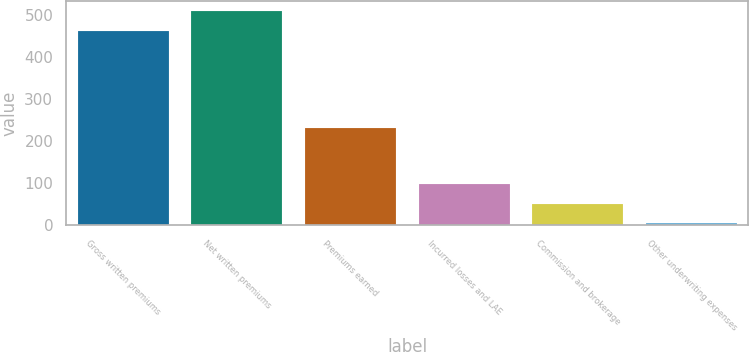Convert chart to OTSL. <chart><loc_0><loc_0><loc_500><loc_500><bar_chart><fcel>Gross written premiums<fcel>Net written premiums<fcel>Premiums earned<fcel>Incurred losses and LAE<fcel>Commission and brokerage<fcel>Other underwriting expenses<nl><fcel>461.3<fcel>507.38<fcel>230.9<fcel>97.76<fcel>51.68<fcel>5.6<nl></chart> 